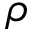<formula> <loc_0><loc_0><loc_500><loc_500>\rho</formula> 